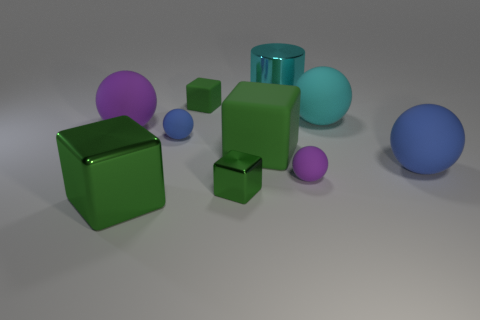What number of rubber things are in front of the tiny green matte thing?
Your answer should be compact. 6. Is there a tiny block made of the same material as the big blue ball?
Ensure brevity in your answer.  Yes. Are there more cyan things that are in front of the big purple ball than big things to the left of the big cyan metal cylinder?
Your answer should be very brief. No. What size is the cyan shiny object?
Offer a very short reply. Large. There is a tiny green object in front of the big blue rubber object; what shape is it?
Give a very brief answer. Cube. Does the large cyan matte object have the same shape as the tiny blue thing?
Provide a short and direct response. Yes. Is the number of small green metal things that are behind the tiny purple matte object the same as the number of cyan rubber spheres?
Offer a very short reply. No. There is a small purple thing; what shape is it?
Provide a short and direct response. Sphere. Is there any other thing that is the same color as the tiny metallic block?
Your answer should be very brief. Yes. Does the blue matte sphere that is left of the large cyan rubber ball have the same size as the cyan object on the right side of the cyan shiny cylinder?
Offer a terse response. No. 